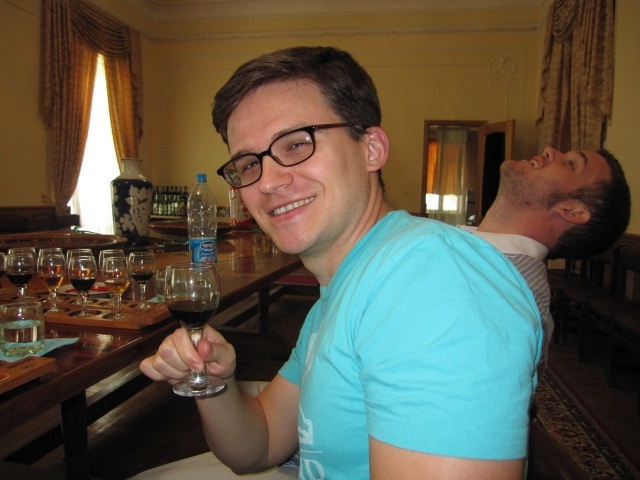Describe the objects in this image and their specific colors. I can see people in maroon, lightblue, gray, teal, and black tones, dining table in maroon, black, and gray tones, people in maroon, black, and brown tones, chair in black and maroon tones, and wine glass in maroon, black, and gray tones in this image. 